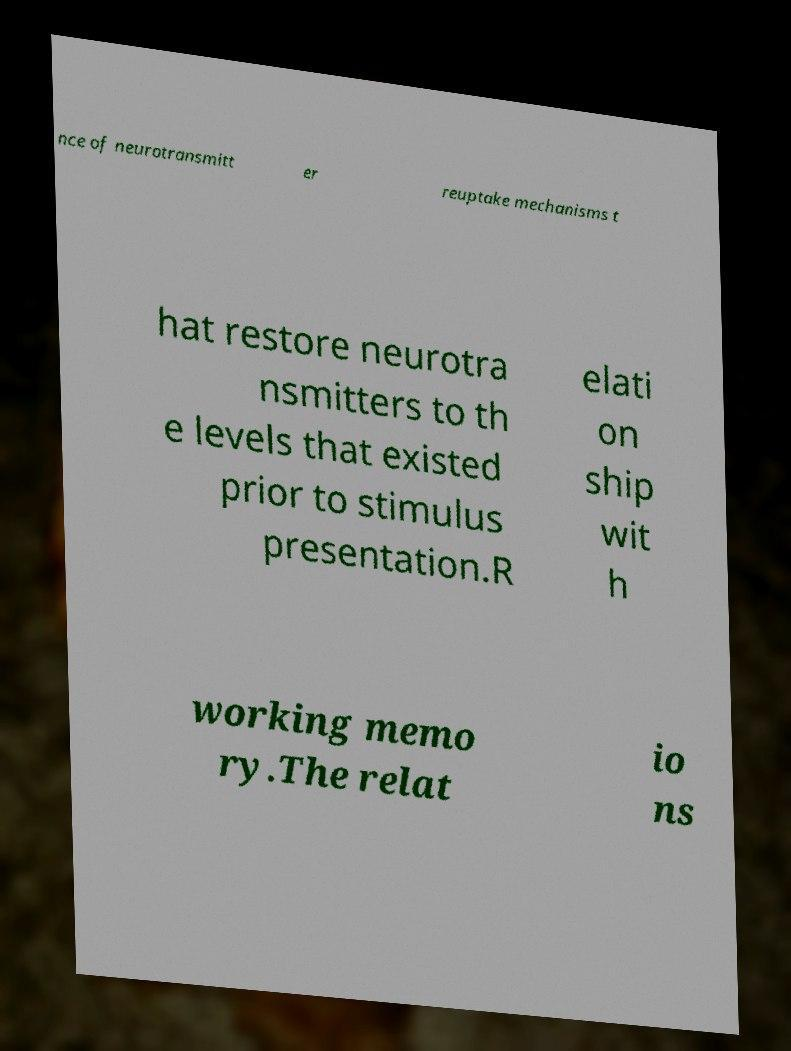Can you read and provide the text displayed in the image?This photo seems to have some interesting text. Can you extract and type it out for me? nce of neurotransmitt er reuptake mechanisms t hat restore neurotra nsmitters to th e levels that existed prior to stimulus presentation.R elati on ship wit h working memo ry.The relat io ns 